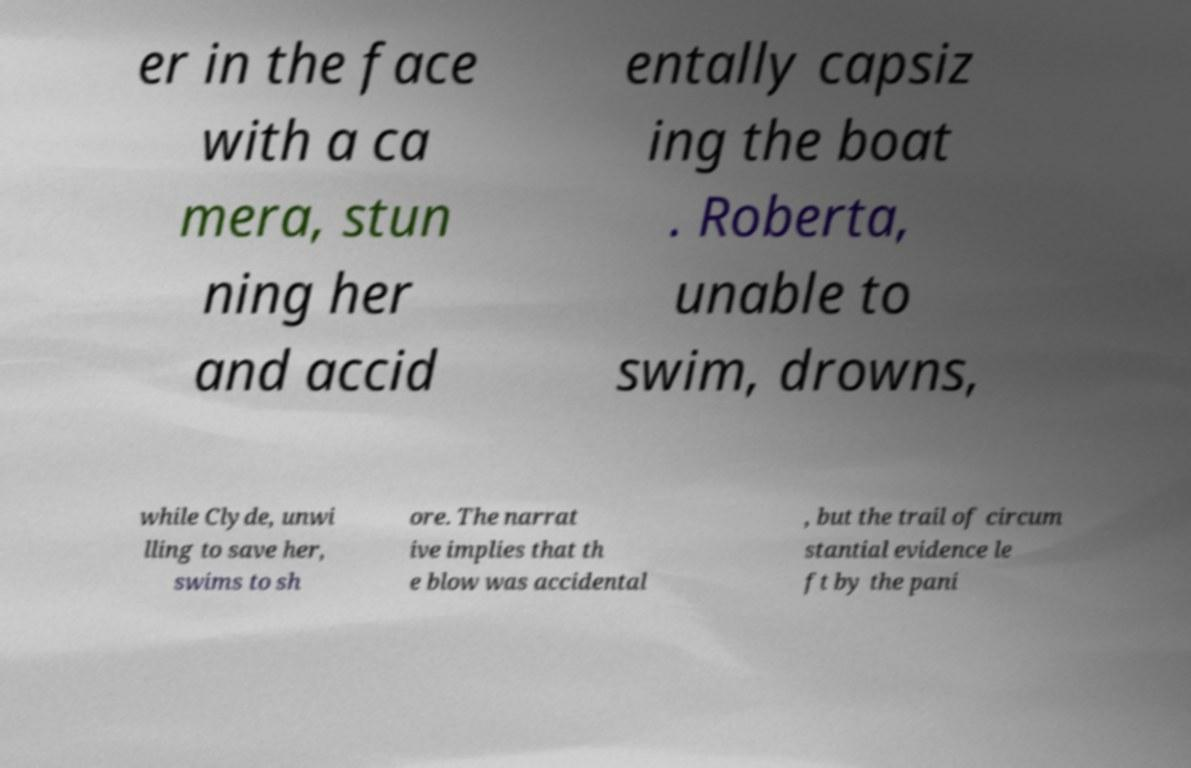Please read and relay the text visible in this image. What does it say? er in the face with a ca mera, stun ning her and accid entally capsiz ing the boat . Roberta, unable to swim, drowns, while Clyde, unwi lling to save her, swims to sh ore. The narrat ive implies that th e blow was accidental , but the trail of circum stantial evidence le ft by the pani 